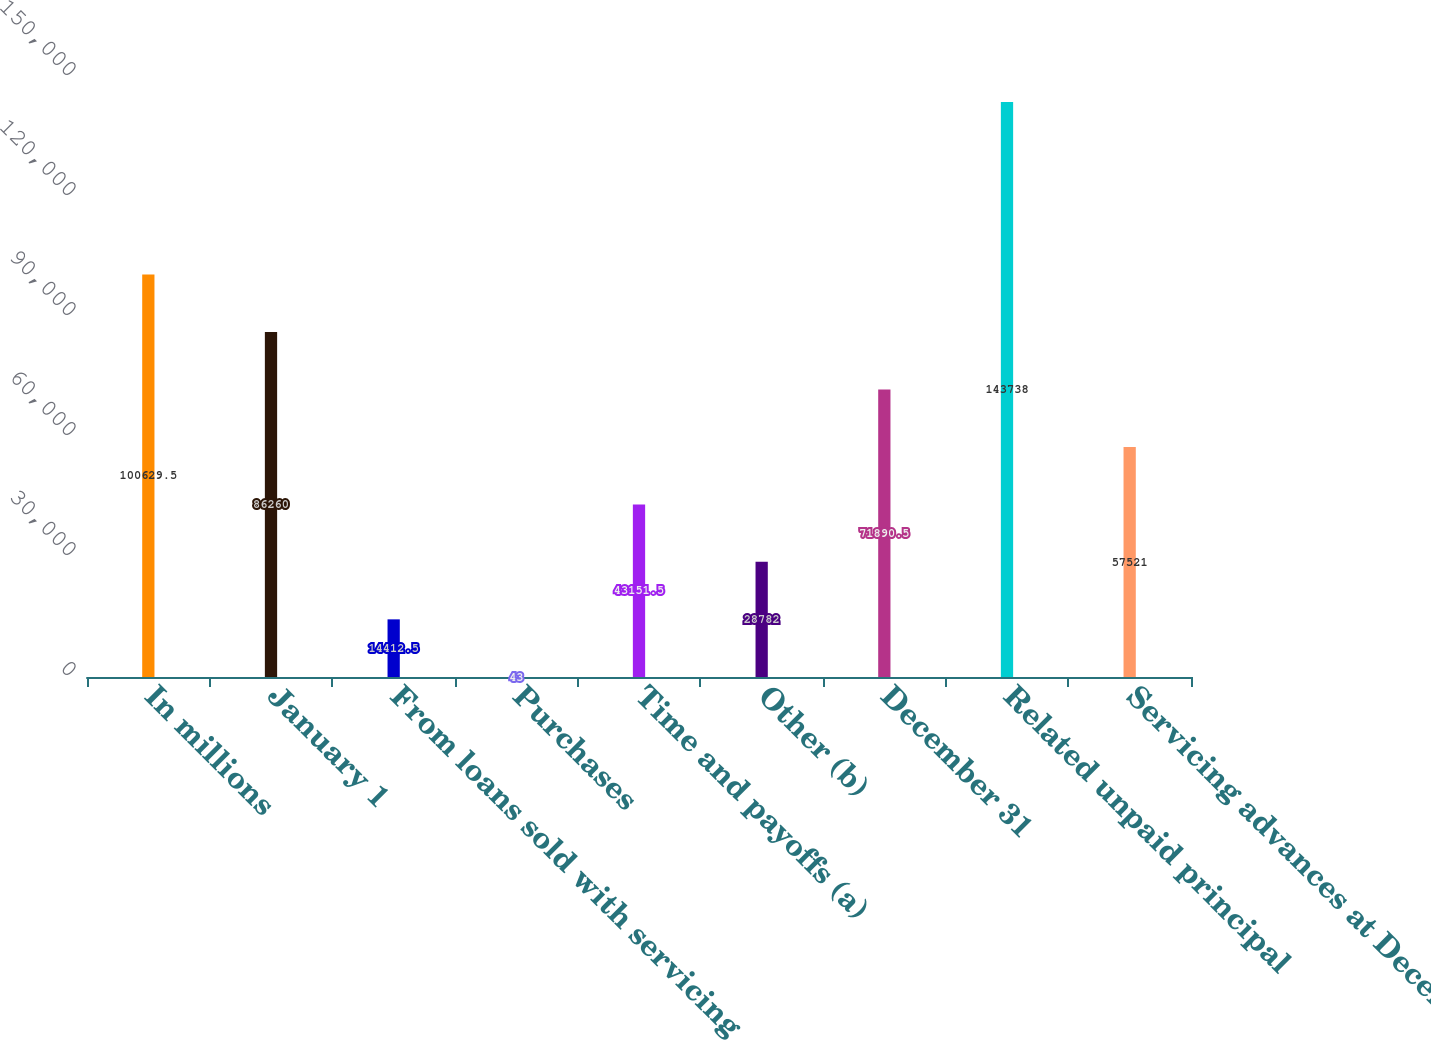Convert chart to OTSL. <chart><loc_0><loc_0><loc_500><loc_500><bar_chart><fcel>In millions<fcel>January 1<fcel>From loans sold with servicing<fcel>Purchases<fcel>Time and payoffs (a)<fcel>Other (b)<fcel>December 31<fcel>Related unpaid principal<fcel>Servicing advances at December<nl><fcel>100630<fcel>86260<fcel>14412.5<fcel>43<fcel>43151.5<fcel>28782<fcel>71890.5<fcel>143738<fcel>57521<nl></chart> 